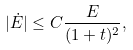Convert formula to latex. <formula><loc_0><loc_0><loc_500><loc_500>| \dot { E } | \leq C \frac { E } { ( 1 + t ) ^ { 2 } } ,</formula> 